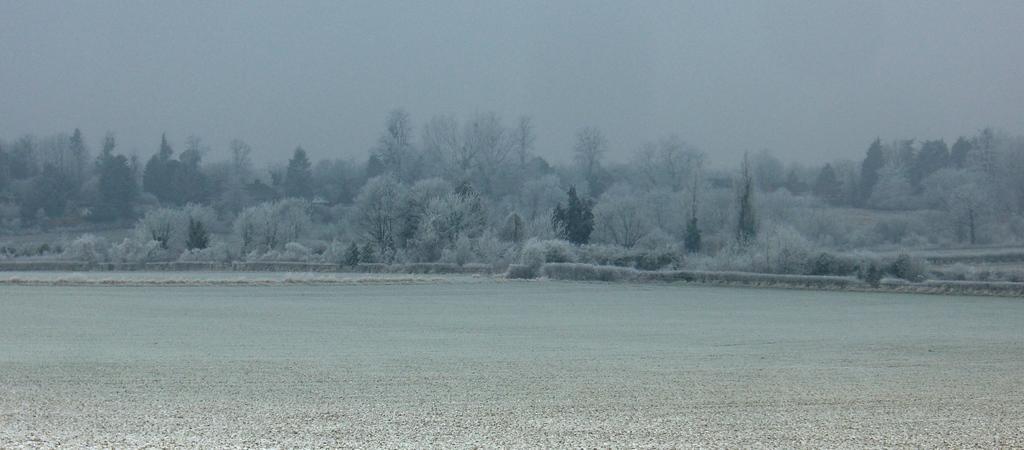Can you describe this image briefly? In this image we can see the road and trees covered with snow. In the background, we can see the sky. 